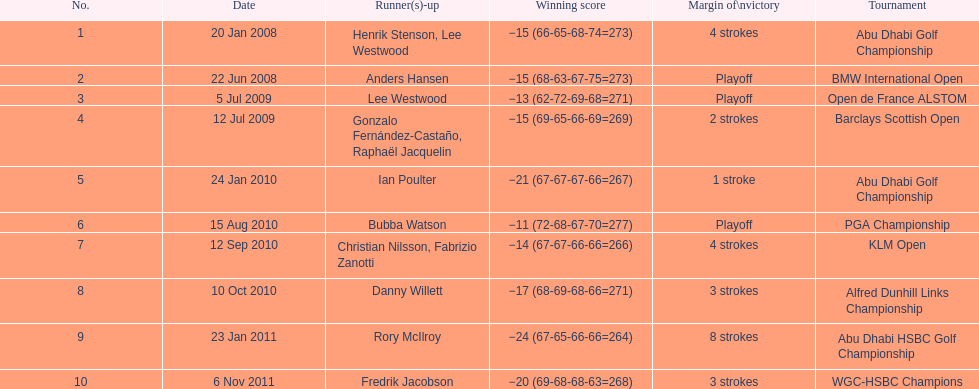How many winning scores were less than -14? 2. Can you give me this table as a dict? {'header': ['No.', 'Date', 'Runner(s)-up', 'Winning score', 'Margin of\\nvictory', 'Tournament'], 'rows': [['1', '20 Jan 2008', 'Henrik Stenson, Lee Westwood', '−15 (66-65-68-74=273)', '4 strokes', 'Abu Dhabi Golf Championship'], ['2', '22 Jun 2008', 'Anders Hansen', '−15 (68-63-67-75=273)', 'Playoff', 'BMW International Open'], ['3', '5 Jul 2009', 'Lee Westwood', '−13 (62-72-69-68=271)', 'Playoff', 'Open de France ALSTOM'], ['4', '12 Jul 2009', 'Gonzalo Fernández-Castaño, Raphaël Jacquelin', '−15 (69-65-66-69=269)', '2 strokes', 'Barclays Scottish Open'], ['5', '24 Jan 2010', 'Ian Poulter', '−21 (67-67-67-66=267)', '1 stroke', 'Abu Dhabi Golf Championship'], ['6', '15 Aug 2010', 'Bubba Watson', '−11 (72-68-67-70=277)', 'Playoff', 'PGA Championship'], ['7', '12 Sep 2010', 'Christian Nilsson, Fabrizio Zanotti', '−14 (67-67-66-66=266)', '4 strokes', 'KLM Open'], ['8', '10 Oct 2010', 'Danny Willett', '−17 (68-69-68-66=271)', '3 strokes', 'Alfred Dunhill Links Championship'], ['9', '23 Jan 2011', 'Rory McIlroy', '−24 (67-65-66-66=264)', '8 strokes', 'Abu Dhabi HSBC Golf Championship'], ['10', '6 Nov 2011', 'Fredrik Jacobson', '−20 (69-68-68-63=268)', '3 strokes', 'WGC-HSBC Champions']]} 